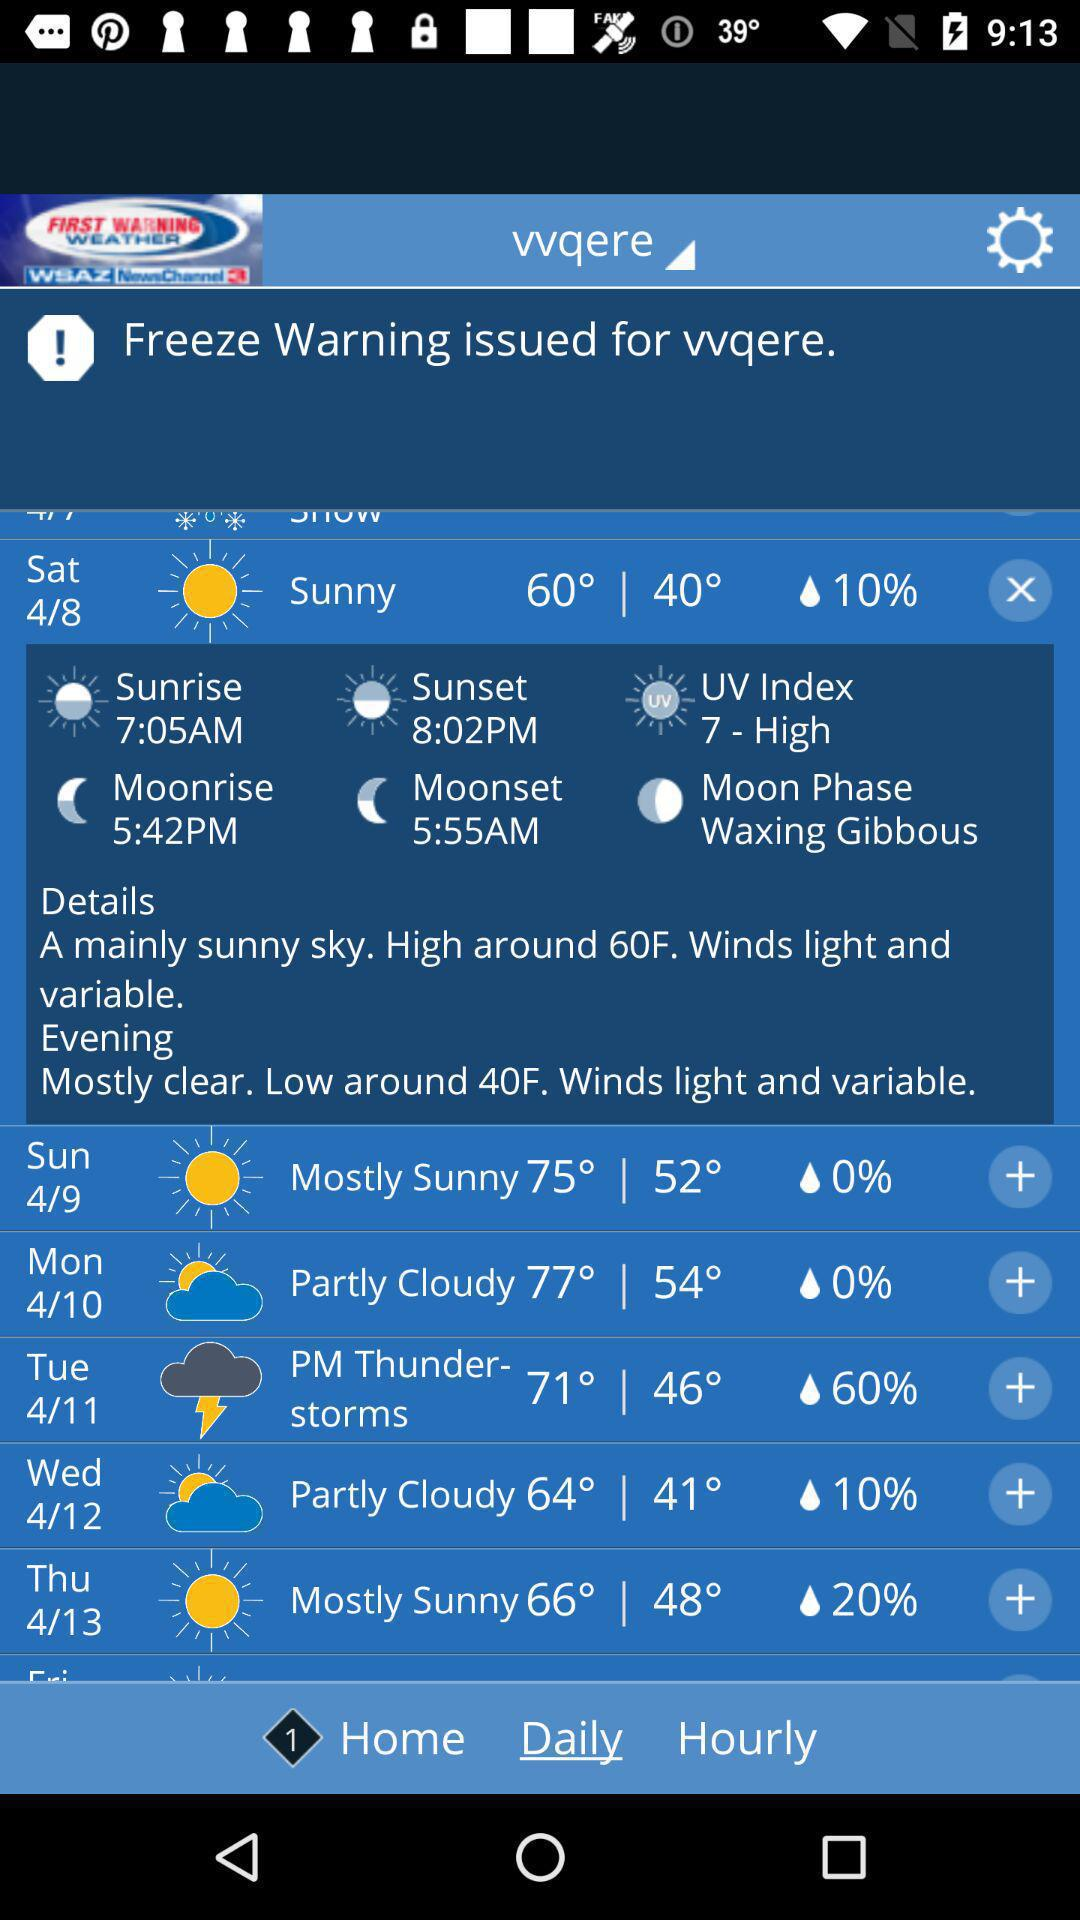What is the high temperature for Wednesday?
Answer the question using a single word or phrase. 64° 